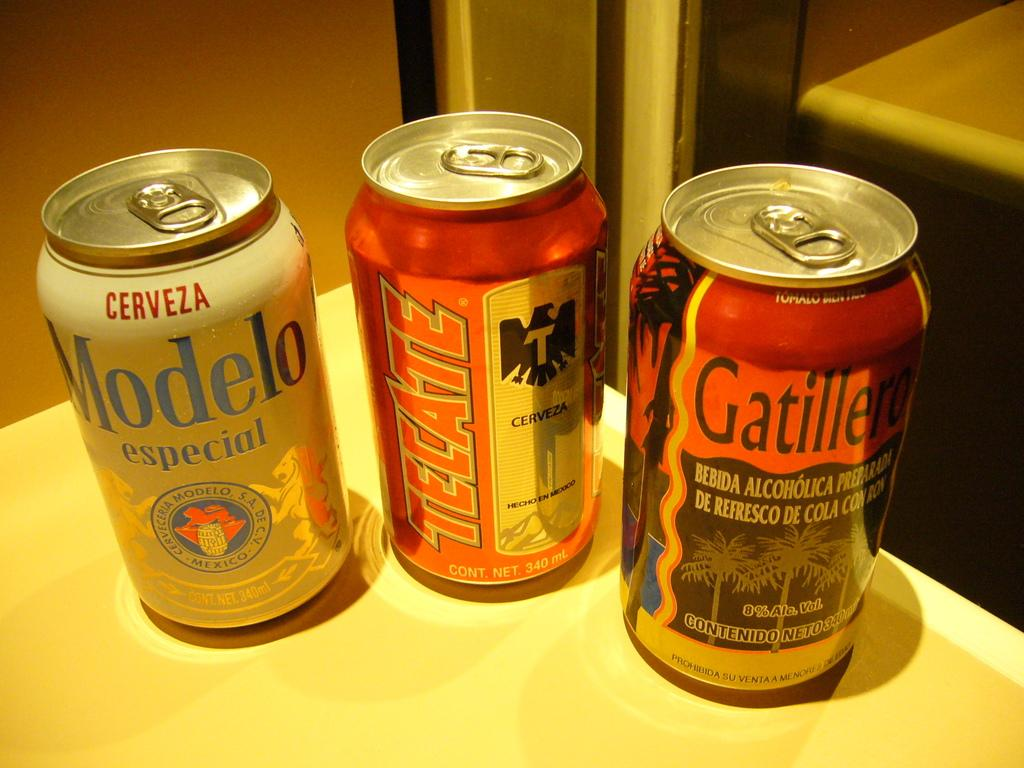<image>
Describe the image concisely. Three cans of beer that say Modelo, Tecate, and Gatillero are on a counter. 